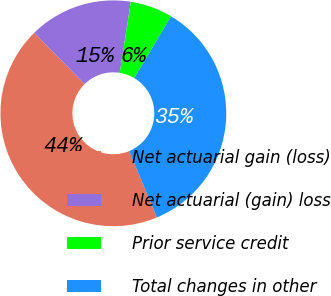<chart> <loc_0><loc_0><loc_500><loc_500><pie_chart><fcel>Net actuarial gain (loss)<fcel>Net actuarial (gain) loss<fcel>Prior service credit<fcel>Total changes in other<nl><fcel>43.94%<fcel>14.85%<fcel>6.06%<fcel>35.15%<nl></chart> 